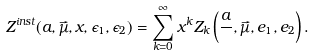<formula> <loc_0><loc_0><loc_500><loc_500>Z ^ { i n s t } ( a , \vec { \mu } , x , \epsilon _ { 1 } , \epsilon _ { 2 } ) = \sum _ { k = 0 } ^ { \infty } x ^ { k } Z _ { k } \left ( \frac { a } { } , \vec { \mu } , e _ { 1 } , e _ { 2 } \right ) .</formula> 